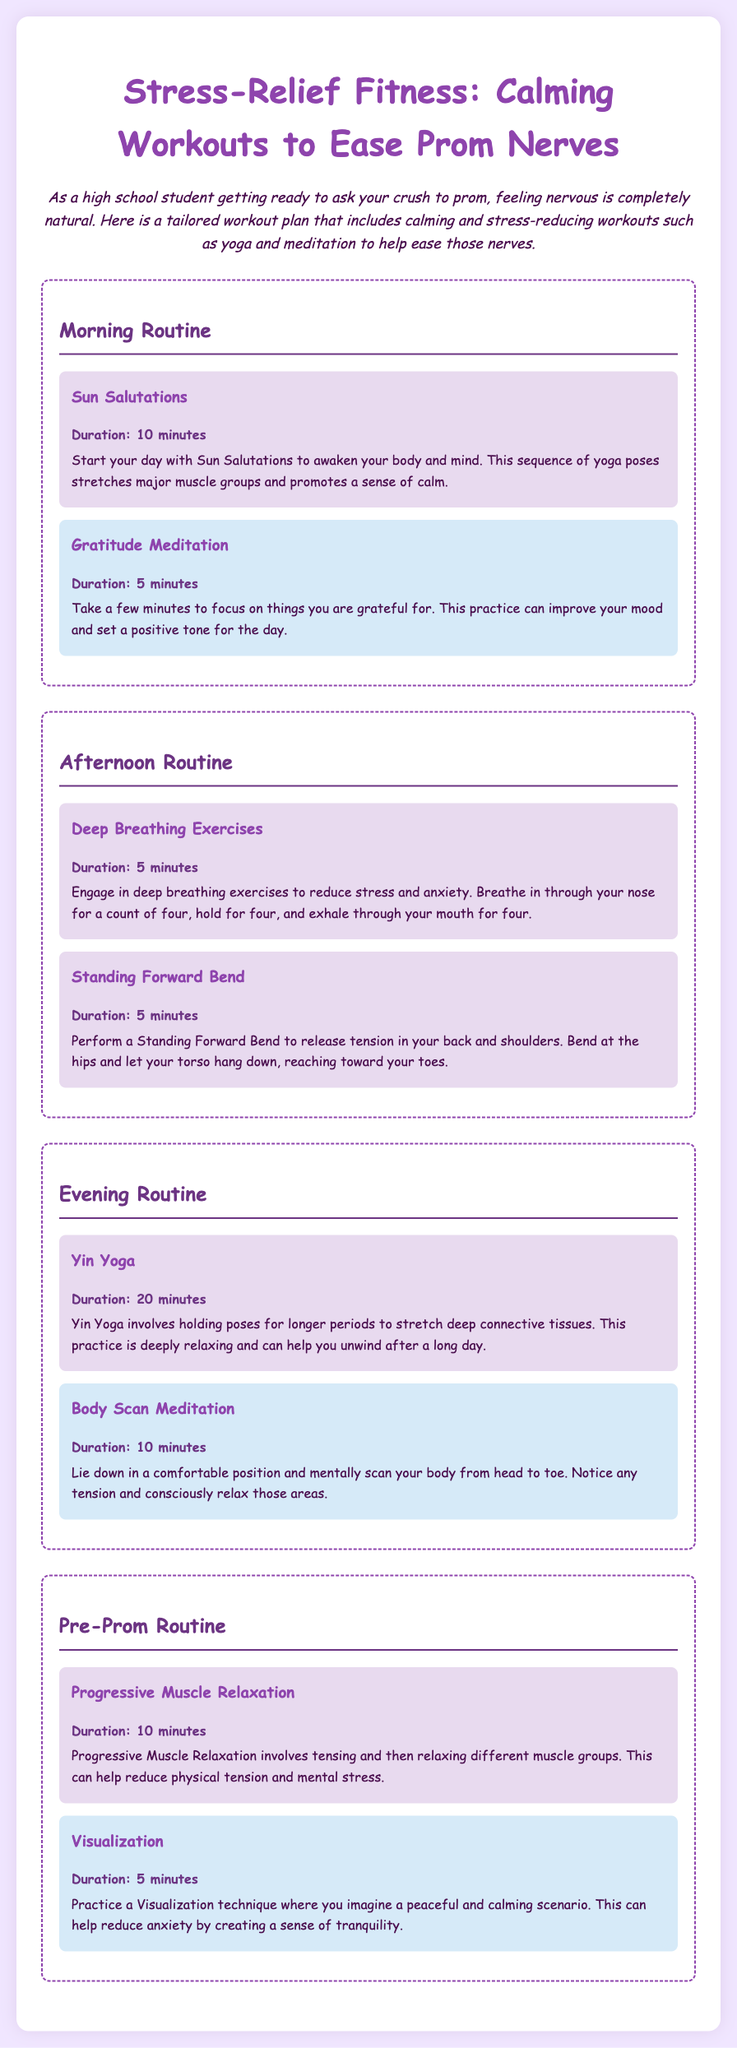What is the title of the document? The title appears at the top of the document and is focused on stress-relief workouts.
Answer: Stress-Relief Fitness: Calming Workouts to Ease Prom Nerves How long is the Sun Salutations workout? The duration is mentioned in the workout section for Sun Salutations.
Answer: 10 minutes What type of meditation is included in the Morning Routine? The meditation type is specified as part of the Morning Routine.
Answer: Gratitude Meditation How many minutes is recommended for the Body Scan Meditation? The duration for the Body Scan Meditation is clearly stated in the Evening Routine.
Answer: 10 minutes What exercise helps to release tension in the back and shoulders? This exercise is specifically mentioned in the Afternoon Routine section.
Answer: Standing Forward Bend What is the duration for the Pre-Prom Progressive Muscle Relaxation? The duration is mentioned in the section for Pre-Prom Routine exercises.
Answer: 10 minutes What is the purpose of Visualization in the Pre-Prom Routine? The purpose is stated in the description of the Visualization exercise.
Answer: Reduce anxiety Which section contains the Yin Yoga exercise? The specific section where Yin Yoga is mentioned is clearly labeled in the document.
Answer: Evening Routine What kind of yoga is suggested for calming workouts? The type of yoga is referred to throughout the document as a stress relief exercise.
Answer: Yin Yoga 